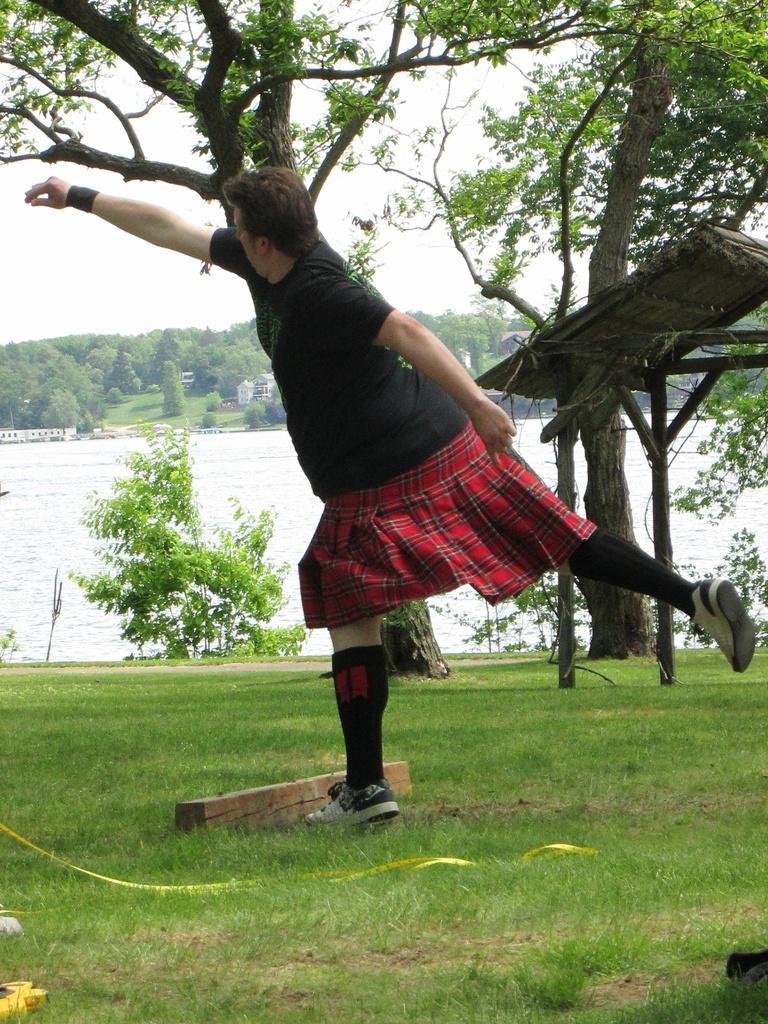Describe this image in one or two sentences. A person is standing wearing a black t shirt and a skirt. There is grass, trees and water. 